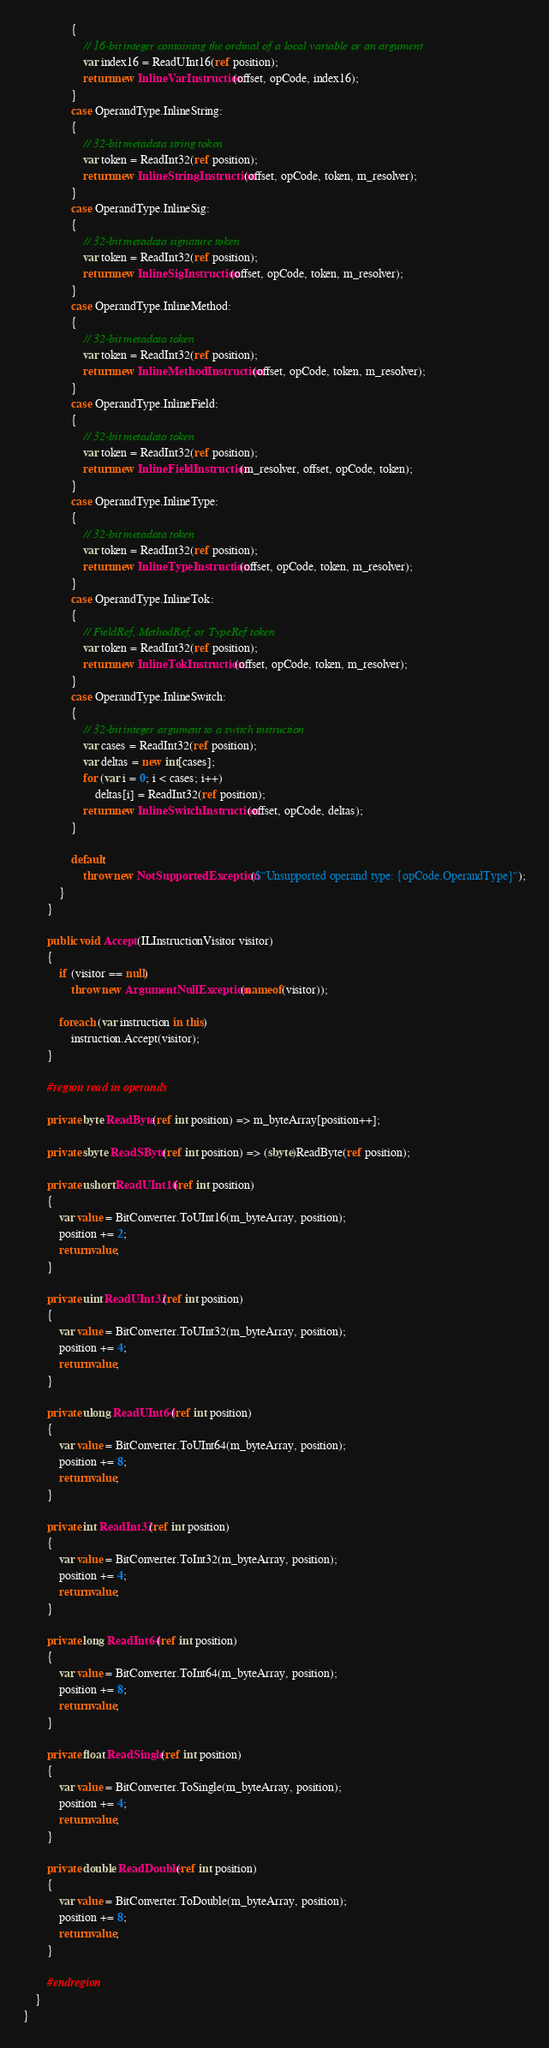<code> <loc_0><loc_0><loc_500><loc_500><_C#_>                {
                    // 16-bit integer containing the ordinal of a local variable or an argument
                    var index16 = ReadUInt16(ref position);
                    return new InlineVarInstruction(offset, opCode, index16);
                }
                case OperandType.InlineString:
                {
                    // 32-bit metadata string token
                    var token = ReadInt32(ref position);
                    return new InlineStringInstruction(offset, opCode, token, m_resolver);
                }
                case OperandType.InlineSig:
                {
                    // 32-bit metadata signature token
                    var token = ReadInt32(ref position);
                    return new InlineSigInstruction(offset, opCode, token, m_resolver);
                }
                case OperandType.InlineMethod:
                {
                    // 32-bit metadata token
                    var token = ReadInt32(ref position);
                    return new InlineMethodInstruction(offset, opCode, token, m_resolver);
                }
                case OperandType.InlineField:
                {
                    // 32-bit metadata token
                    var token = ReadInt32(ref position);
                    return new InlineFieldInstruction(m_resolver, offset, opCode, token);
                }
                case OperandType.InlineType:
                {
                    // 32-bit metadata token
                    var token = ReadInt32(ref position);
                    return new InlineTypeInstruction(offset, opCode, token, m_resolver);
                }
                case OperandType.InlineTok:
                {
                    // FieldRef, MethodRef, or TypeRef token
                    var token = ReadInt32(ref position);
                    return new InlineTokInstruction(offset, opCode, token, m_resolver);
                }
                case OperandType.InlineSwitch:
                {
                    // 32-bit integer argument to a switch instruction
                    var cases = ReadInt32(ref position);
                    var deltas = new int[cases];
                    for (var i = 0; i < cases; i++)
                        deltas[i] = ReadInt32(ref position);
                    return new InlineSwitchInstruction(offset, opCode, deltas);
                }

                default:
                    throw new NotSupportedException($"Unsupported operand type: {opCode.OperandType}");
            }
        }

        public void Accept(ILInstructionVisitor visitor)
        {
            if (visitor == null)
                throw new ArgumentNullException(nameof(visitor));

            foreach (var instruction in this)
                instruction.Accept(visitor);
        }

        #region read in operands

        private byte ReadByte(ref int position) => m_byteArray[position++];

        private sbyte ReadSByte(ref int position) => (sbyte)ReadByte(ref position);

        private ushort ReadUInt16(ref int position)
        {
            var value = BitConverter.ToUInt16(m_byteArray, position);
            position += 2;
            return value;
        }

        private uint ReadUInt32(ref int position)
        {
            var value = BitConverter.ToUInt32(m_byteArray, position);
            position += 4;
            return value;
        }

        private ulong ReadUInt64(ref int position)
        {
            var value = BitConverter.ToUInt64(m_byteArray, position);
            position += 8;
            return value;
        }

        private int ReadInt32(ref int position)
        {
            var value = BitConverter.ToInt32(m_byteArray, position);
            position += 4;
            return value;
        }

        private long ReadInt64(ref int position)
        {
            var value = BitConverter.ToInt64(m_byteArray, position);
            position += 8;
            return value;
        }

        private float ReadSingle(ref int position)
        {
            var value = BitConverter.ToSingle(m_byteArray, position);
            position += 4;
            return value;
        }

        private double ReadDouble(ref int position)
        {
            var value = BitConverter.ToDouble(m_byteArray, position);
            position += 8;
            return value;
        }

        #endregion
    }
}</code> 